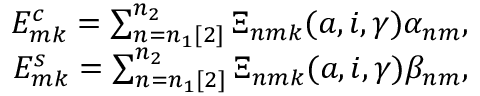Convert formula to latex. <formula><loc_0><loc_0><loc_500><loc_500>\begin{array} { r } { E _ { m k } ^ { c } = \sum _ { n = n _ { 1 } [ 2 ] } ^ { n _ { 2 } } \Xi _ { n m k } ( a , i , \gamma ) \alpha _ { n m } , } \\ { E _ { m k } ^ { s } = \sum _ { n = n _ { 1 } [ 2 ] } ^ { n _ { 2 } } \Xi _ { n m k } ( a , i , \gamma ) \beta _ { n m } , } \end{array}</formula> 